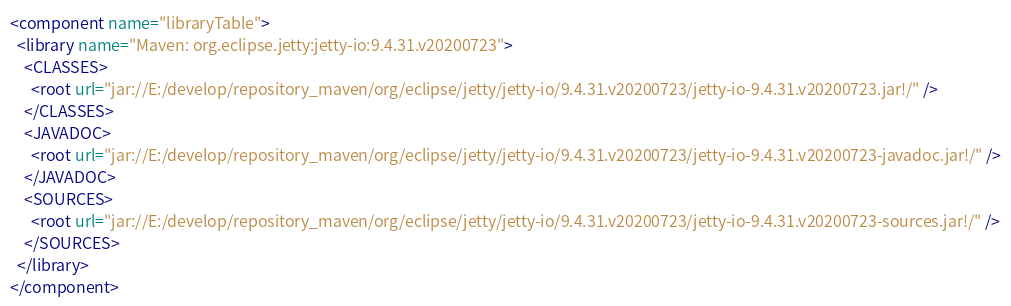Convert code to text. <code><loc_0><loc_0><loc_500><loc_500><_XML_><component name="libraryTable">
  <library name="Maven: org.eclipse.jetty:jetty-io:9.4.31.v20200723">
    <CLASSES>
      <root url="jar://E:/develop/repository_maven/org/eclipse/jetty/jetty-io/9.4.31.v20200723/jetty-io-9.4.31.v20200723.jar!/" />
    </CLASSES>
    <JAVADOC>
      <root url="jar://E:/develop/repository_maven/org/eclipse/jetty/jetty-io/9.4.31.v20200723/jetty-io-9.4.31.v20200723-javadoc.jar!/" />
    </JAVADOC>
    <SOURCES>
      <root url="jar://E:/develop/repository_maven/org/eclipse/jetty/jetty-io/9.4.31.v20200723/jetty-io-9.4.31.v20200723-sources.jar!/" />
    </SOURCES>
  </library>
</component></code> 